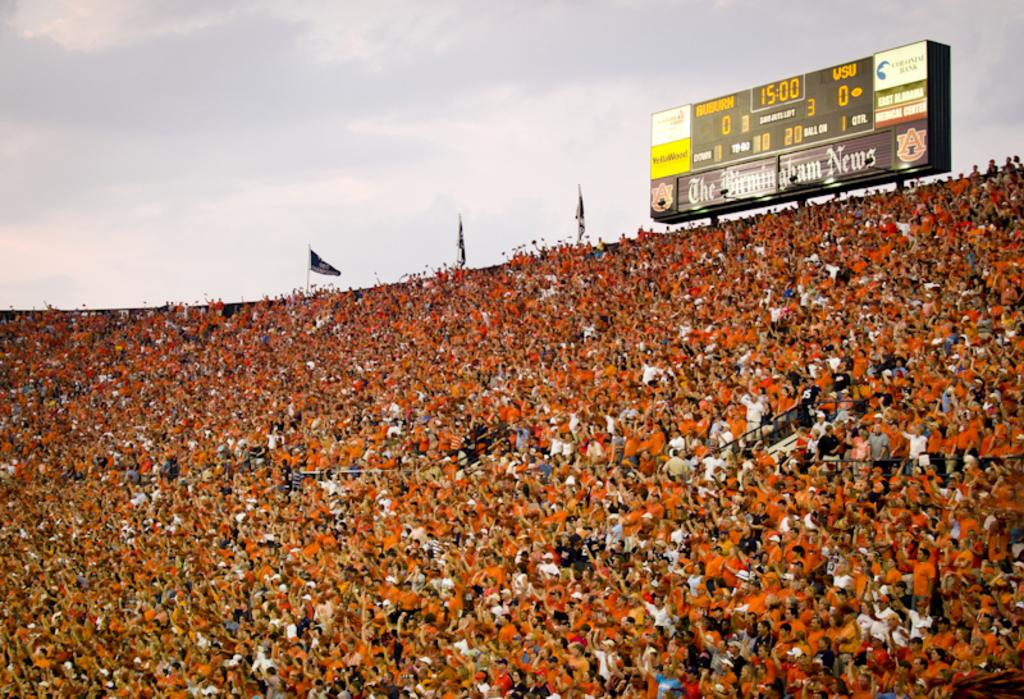Provide a one-sentence caption for the provided image. A very packed stadium shows a scoreboard with a tied game at 15:00. 